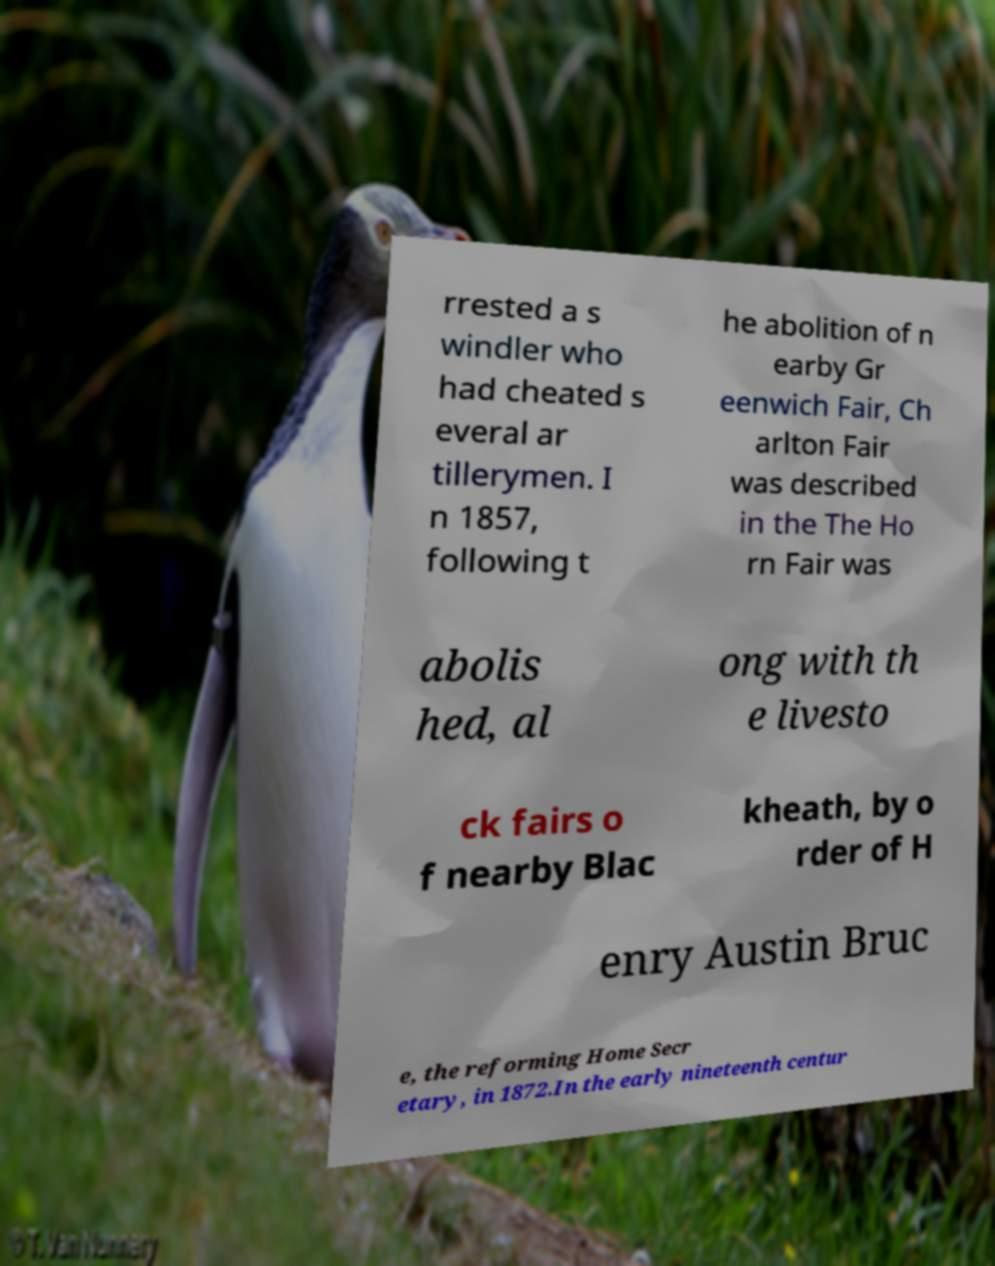Please identify and transcribe the text found in this image. rrested a s windler who had cheated s everal ar tillerymen. I n 1857, following t he abolition of n earby Gr eenwich Fair, Ch arlton Fair was described in the The Ho rn Fair was abolis hed, al ong with th e livesto ck fairs o f nearby Blac kheath, by o rder of H enry Austin Bruc e, the reforming Home Secr etary, in 1872.In the early nineteenth centur 